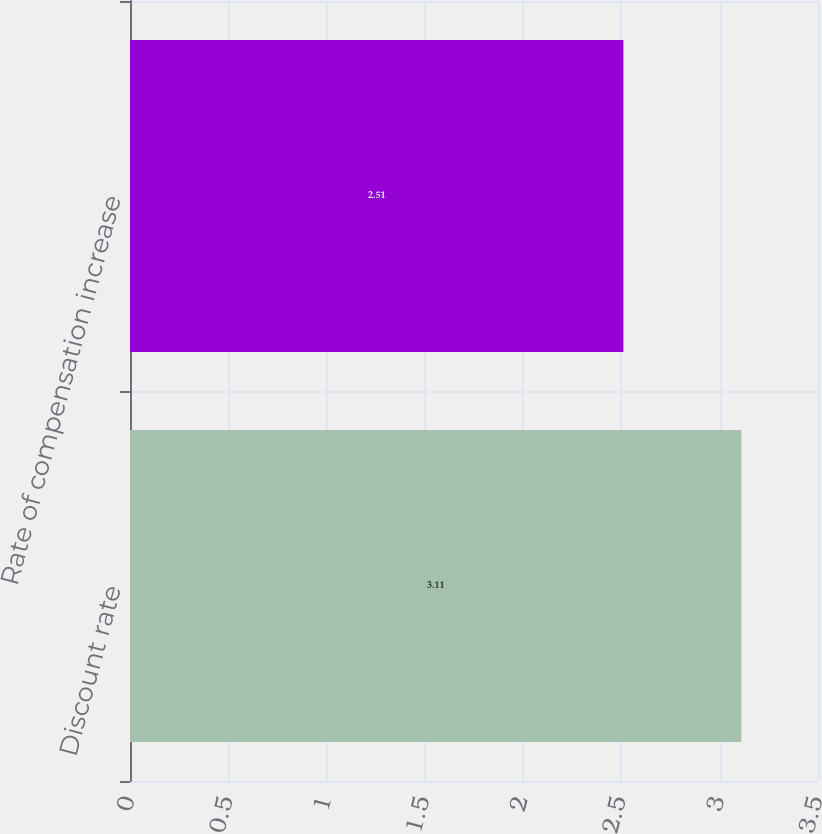Convert chart to OTSL. <chart><loc_0><loc_0><loc_500><loc_500><bar_chart><fcel>Discount rate<fcel>Rate of compensation increase<nl><fcel>3.11<fcel>2.51<nl></chart> 